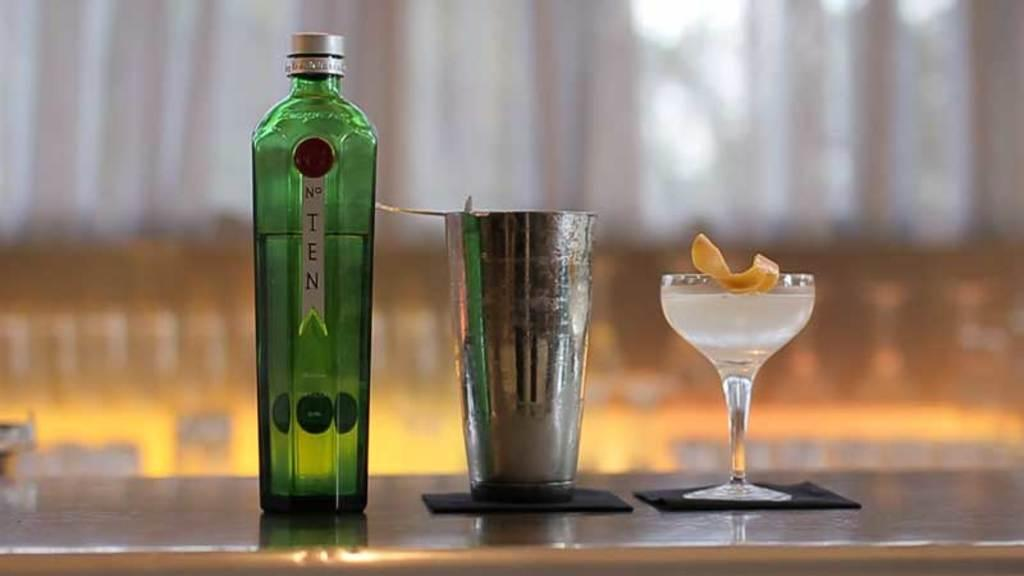What type of bottle is visible in the image? There is a glass bottle in the image. What other type of glass is present in the image? There is a steel glass in the image. What is the third type of glass in the image? There is a wine glass in the image. How many jellyfish are swimming in the glass bottle in the image? There are no jellyfish present in the image, as it features three types of glasses: a glass bottle, a steel glass, and a wine glass. 